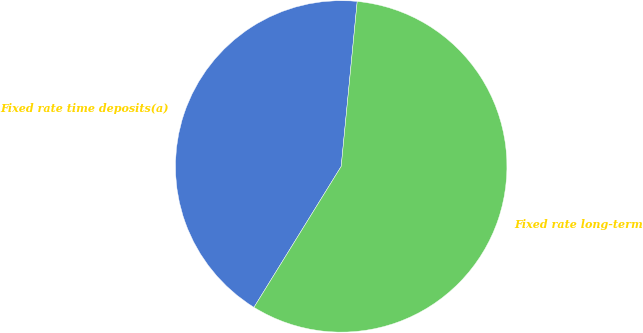<chart> <loc_0><loc_0><loc_500><loc_500><pie_chart><fcel>Fixed rate time deposits(a)<fcel>Fixed rate long-term<nl><fcel>42.72%<fcel>57.28%<nl></chart> 